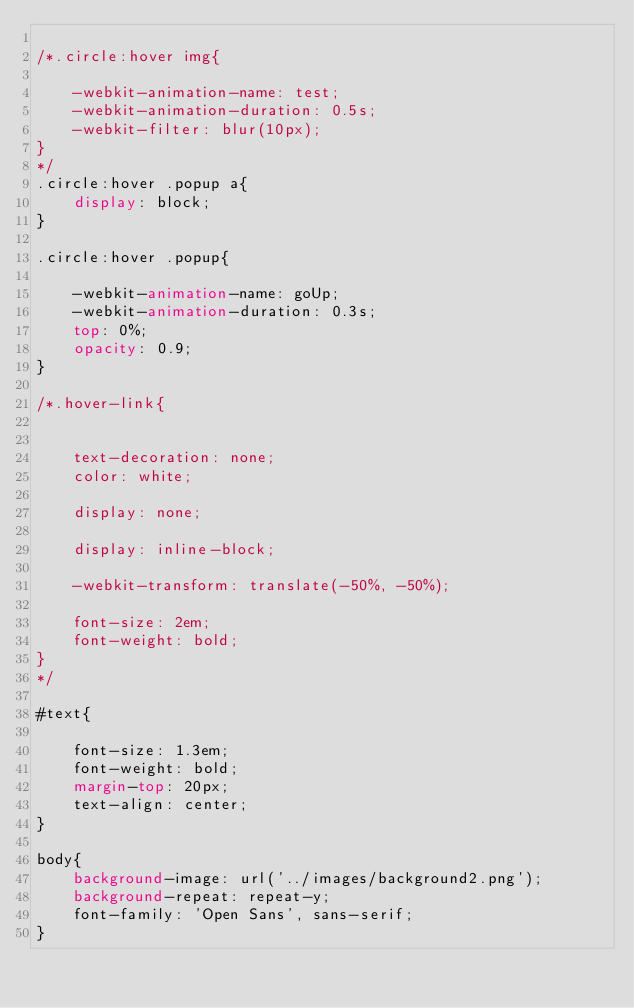Convert code to text. <code><loc_0><loc_0><loc_500><loc_500><_CSS_>
/*.circle:hover img{

	-webkit-animation-name: test;
	-webkit-animation-duration: 0.5s;
	-webkit-filter: blur(10px);
}
*/
.circle:hover .popup a{
	display: block;
}

.circle:hover .popup{

	-webkit-animation-name: goUp;
	-webkit-animation-duration: 0.3s;
	top: 0%;
	opacity: 0.9;
}

/*.hover-link{

	
	text-decoration: none;
	color: white;

	display: none;

	display: inline-block;

	-webkit-transform: translate(-50%, -50%);

	font-size: 2em;
	font-weight: bold;
}
*/

#text{

	font-size: 1.3em;
	font-weight: bold;
	margin-top: 20px;
	text-align: center;
}

body{
	background-image: url('../images/background2.png');
	background-repeat: repeat-y;
	font-family: 'Open Sans', sans-serif;
}</code> 